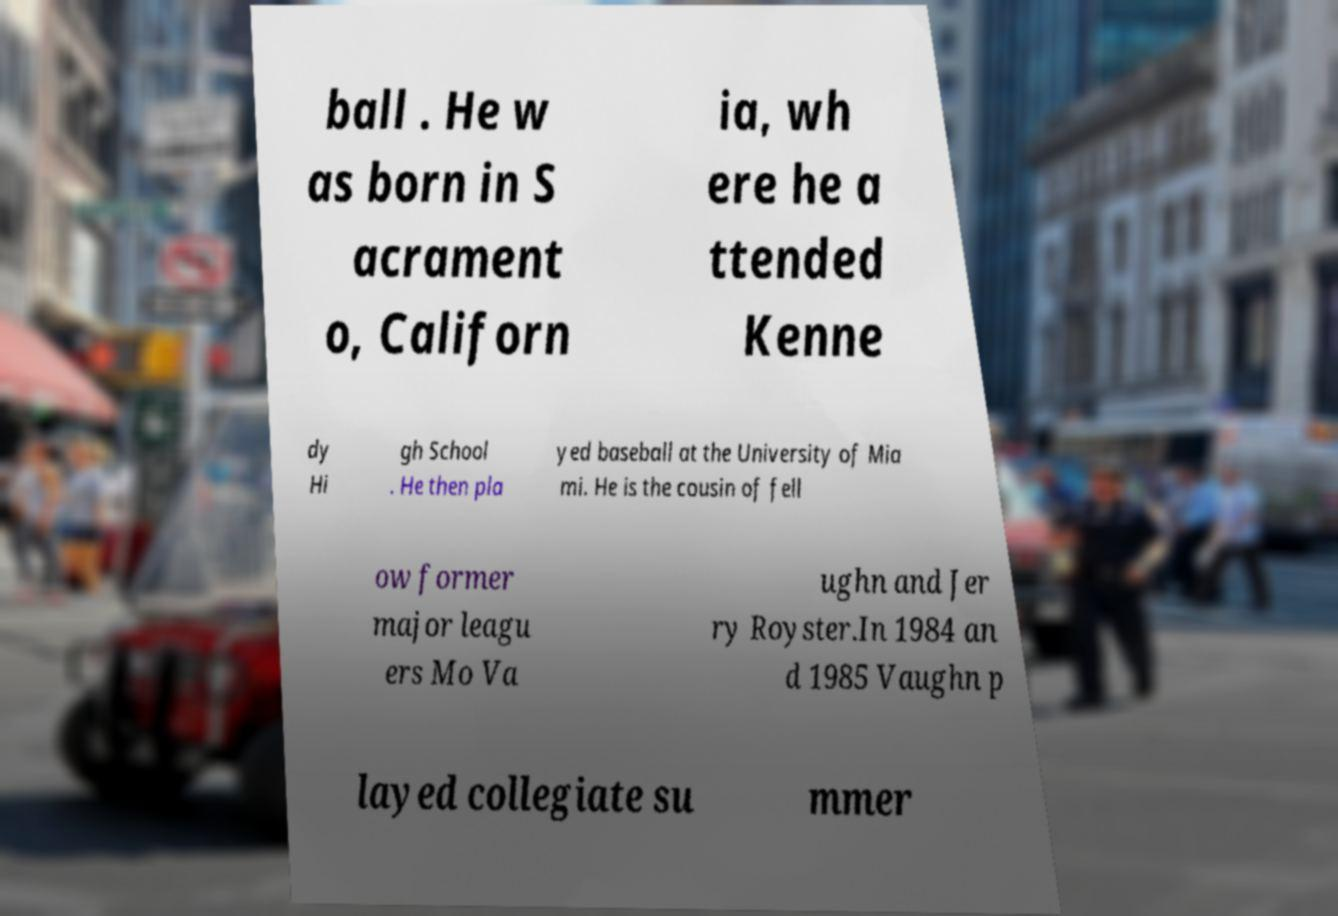Can you read and provide the text displayed in the image?This photo seems to have some interesting text. Can you extract and type it out for me? ball . He w as born in S acrament o, Californ ia, wh ere he a ttended Kenne dy Hi gh School . He then pla yed baseball at the University of Mia mi. He is the cousin of fell ow former major leagu ers Mo Va ughn and Jer ry Royster.In 1984 an d 1985 Vaughn p layed collegiate su mmer 